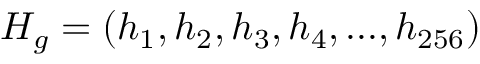Convert formula to latex. <formula><loc_0><loc_0><loc_500><loc_500>H _ { g } = ( h _ { 1 } , h _ { 2 } , h _ { 3 } , h _ { 4 } , \dots , h _ { 2 5 6 } )</formula> 